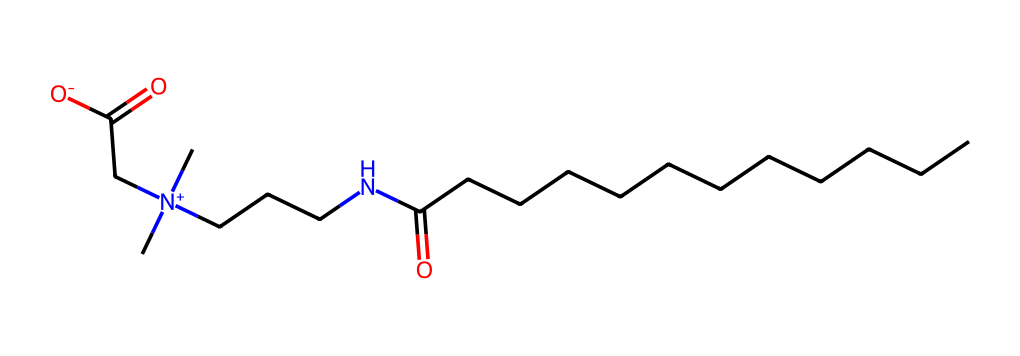What is the main functional group present in cocamidopropyl betaine? The chemical structure indicates the presence of a carboxylate group (–COO⁻) which is characteristic of surfactants, particularly on the end of the long alkyl chain, making it amphoteric.
Answer: carboxylate How many carbon atoms are in cocamidopropyl betaine? By analyzing the structure, we can count the carbon atoms represented in the formula: there are 14 carbon atoms from the fatty acid part and the betaine moiety.
Answer: 14 What type of surfactant is cocamidopropyl betaine classified as? Looking at its chemical structure, which has both a hydrophilic part (the betaine structure) and a hydrophobic alkyl chain, it can be identified as an amphoteric surfactant.
Answer: amphoteric How many nitrogen atoms are in cocamidopropyl betaine? In the provided SMILES representation, there are two nitrogen atoms present in the betaine structure (indicated by N and [N+]).
Answer: 2 What physical state is cocamidopropyl betaine likely to be in at room temperature? Given its chemical structure that embodies both hydrophilic and hydrophobic features, along with its common use in personal care products, it is likely to be a liquid at room temperature.
Answer: liquid What property of cocamidopropyl betaine contributes to its mildness in hand soaps? The presence of the long alkyl chain provides surface activity while the quaternary ammonium group contributes to a conditioning effect, making it gentler on the skin compared to harsher surfactants.
Answer: mildness 